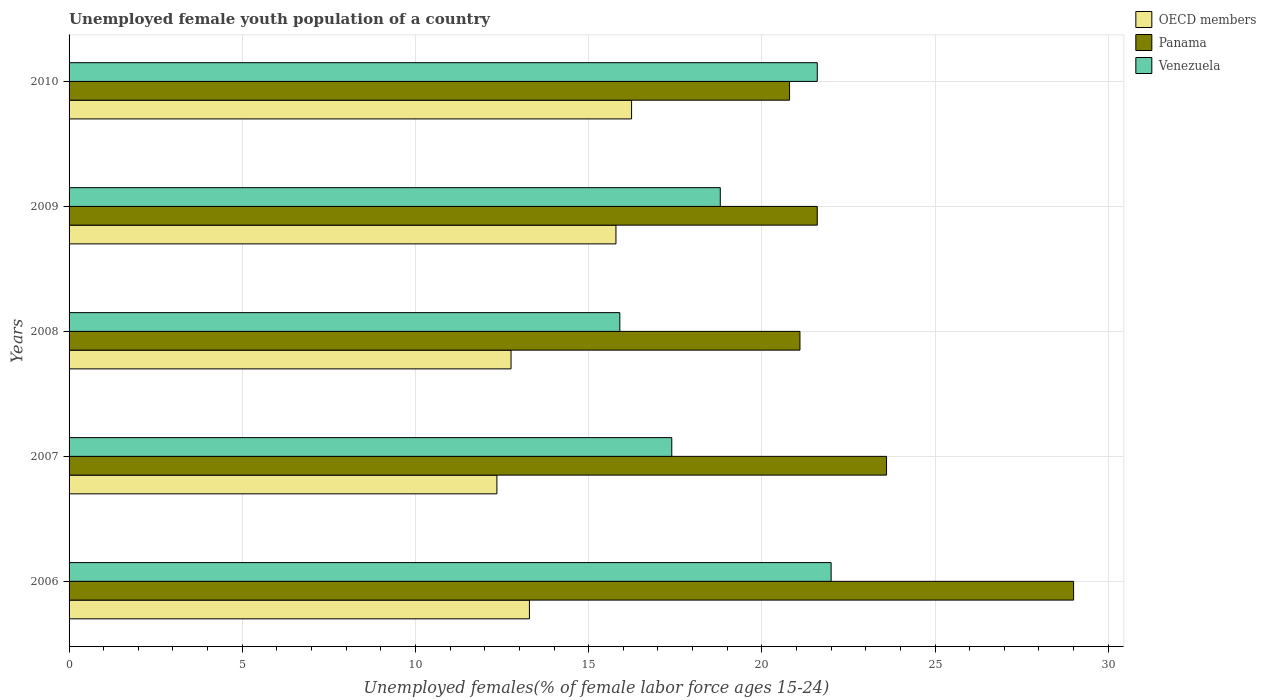How many groups of bars are there?
Your answer should be compact. 5. How many bars are there on the 3rd tick from the bottom?
Your response must be concise. 3. What is the label of the 1st group of bars from the top?
Your response must be concise. 2010. What is the percentage of unemployed female youth population in Venezuela in 2010?
Your answer should be compact. 21.6. Across all years, what is the minimum percentage of unemployed female youth population in Panama?
Your answer should be very brief. 20.8. What is the total percentage of unemployed female youth population in Venezuela in the graph?
Your answer should be compact. 95.7. What is the difference between the percentage of unemployed female youth population in OECD members in 2006 and that in 2010?
Your response must be concise. -2.95. What is the difference between the percentage of unemployed female youth population in Venezuela in 2006 and the percentage of unemployed female youth population in OECD members in 2010?
Give a very brief answer. 5.76. What is the average percentage of unemployed female youth population in OECD members per year?
Offer a very short reply. 14.09. In the year 2009, what is the difference between the percentage of unemployed female youth population in Venezuela and percentage of unemployed female youth population in OECD members?
Provide a succinct answer. 3.01. What is the ratio of the percentage of unemployed female youth population in Panama in 2007 to that in 2009?
Keep it short and to the point. 1.09. Is the percentage of unemployed female youth population in Venezuela in 2006 less than that in 2010?
Ensure brevity in your answer.  No. Is the difference between the percentage of unemployed female youth population in Venezuela in 2006 and 2007 greater than the difference between the percentage of unemployed female youth population in OECD members in 2006 and 2007?
Your answer should be very brief. Yes. What is the difference between the highest and the second highest percentage of unemployed female youth population in Panama?
Make the answer very short. 5.4. What is the difference between the highest and the lowest percentage of unemployed female youth population in OECD members?
Offer a very short reply. 3.89. In how many years, is the percentage of unemployed female youth population in Panama greater than the average percentage of unemployed female youth population in Panama taken over all years?
Your answer should be very brief. 2. Is the sum of the percentage of unemployed female youth population in Venezuela in 2008 and 2009 greater than the maximum percentage of unemployed female youth population in Panama across all years?
Offer a terse response. Yes. What does the 3rd bar from the top in 2010 represents?
Provide a short and direct response. OECD members. What does the 1st bar from the bottom in 2009 represents?
Give a very brief answer. OECD members. How many years are there in the graph?
Your answer should be compact. 5. What is the difference between two consecutive major ticks on the X-axis?
Provide a succinct answer. 5. Are the values on the major ticks of X-axis written in scientific E-notation?
Offer a terse response. No. Where does the legend appear in the graph?
Provide a short and direct response. Top right. How are the legend labels stacked?
Offer a terse response. Vertical. What is the title of the graph?
Ensure brevity in your answer.  Unemployed female youth population of a country. Does "Macao" appear as one of the legend labels in the graph?
Ensure brevity in your answer.  No. What is the label or title of the X-axis?
Provide a succinct answer. Unemployed females(% of female labor force ages 15-24). What is the Unemployed females(% of female labor force ages 15-24) of OECD members in 2006?
Your answer should be very brief. 13.29. What is the Unemployed females(% of female labor force ages 15-24) of OECD members in 2007?
Keep it short and to the point. 12.35. What is the Unemployed females(% of female labor force ages 15-24) in Panama in 2007?
Ensure brevity in your answer.  23.6. What is the Unemployed females(% of female labor force ages 15-24) in Venezuela in 2007?
Your response must be concise. 17.4. What is the Unemployed females(% of female labor force ages 15-24) in OECD members in 2008?
Your response must be concise. 12.76. What is the Unemployed females(% of female labor force ages 15-24) in Panama in 2008?
Give a very brief answer. 21.1. What is the Unemployed females(% of female labor force ages 15-24) in Venezuela in 2008?
Provide a short and direct response. 15.9. What is the Unemployed females(% of female labor force ages 15-24) in OECD members in 2009?
Your answer should be very brief. 15.79. What is the Unemployed females(% of female labor force ages 15-24) in Panama in 2009?
Offer a very short reply. 21.6. What is the Unemployed females(% of female labor force ages 15-24) in Venezuela in 2009?
Provide a succinct answer. 18.8. What is the Unemployed females(% of female labor force ages 15-24) in OECD members in 2010?
Provide a short and direct response. 16.24. What is the Unemployed females(% of female labor force ages 15-24) of Panama in 2010?
Provide a succinct answer. 20.8. What is the Unemployed females(% of female labor force ages 15-24) of Venezuela in 2010?
Offer a terse response. 21.6. Across all years, what is the maximum Unemployed females(% of female labor force ages 15-24) of OECD members?
Offer a terse response. 16.24. Across all years, what is the minimum Unemployed females(% of female labor force ages 15-24) of OECD members?
Your response must be concise. 12.35. Across all years, what is the minimum Unemployed females(% of female labor force ages 15-24) in Panama?
Provide a succinct answer. 20.8. Across all years, what is the minimum Unemployed females(% of female labor force ages 15-24) of Venezuela?
Your answer should be compact. 15.9. What is the total Unemployed females(% of female labor force ages 15-24) of OECD members in the graph?
Your answer should be compact. 70.43. What is the total Unemployed females(% of female labor force ages 15-24) in Panama in the graph?
Offer a terse response. 116.1. What is the total Unemployed females(% of female labor force ages 15-24) in Venezuela in the graph?
Your answer should be very brief. 95.7. What is the difference between the Unemployed females(% of female labor force ages 15-24) in OECD members in 2006 and that in 2007?
Offer a terse response. 0.94. What is the difference between the Unemployed females(% of female labor force ages 15-24) in OECD members in 2006 and that in 2008?
Provide a short and direct response. 0.53. What is the difference between the Unemployed females(% of female labor force ages 15-24) of OECD members in 2006 and that in 2009?
Give a very brief answer. -2.5. What is the difference between the Unemployed females(% of female labor force ages 15-24) of Venezuela in 2006 and that in 2009?
Keep it short and to the point. 3.2. What is the difference between the Unemployed females(% of female labor force ages 15-24) in OECD members in 2006 and that in 2010?
Your response must be concise. -2.95. What is the difference between the Unemployed females(% of female labor force ages 15-24) in Panama in 2006 and that in 2010?
Give a very brief answer. 8.2. What is the difference between the Unemployed females(% of female labor force ages 15-24) in OECD members in 2007 and that in 2008?
Make the answer very short. -0.41. What is the difference between the Unemployed females(% of female labor force ages 15-24) of OECD members in 2007 and that in 2009?
Your answer should be very brief. -3.44. What is the difference between the Unemployed females(% of female labor force ages 15-24) of Venezuela in 2007 and that in 2009?
Give a very brief answer. -1.4. What is the difference between the Unemployed females(% of female labor force ages 15-24) of OECD members in 2007 and that in 2010?
Make the answer very short. -3.89. What is the difference between the Unemployed females(% of female labor force ages 15-24) of Venezuela in 2007 and that in 2010?
Your response must be concise. -4.2. What is the difference between the Unemployed females(% of female labor force ages 15-24) of OECD members in 2008 and that in 2009?
Your answer should be very brief. -3.03. What is the difference between the Unemployed females(% of female labor force ages 15-24) of Panama in 2008 and that in 2009?
Your response must be concise. -0.5. What is the difference between the Unemployed females(% of female labor force ages 15-24) of OECD members in 2008 and that in 2010?
Your answer should be compact. -3.48. What is the difference between the Unemployed females(% of female labor force ages 15-24) of Panama in 2008 and that in 2010?
Make the answer very short. 0.3. What is the difference between the Unemployed females(% of female labor force ages 15-24) in OECD members in 2009 and that in 2010?
Provide a succinct answer. -0.45. What is the difference between the Unemployed females(% of female labor force ages 15-24) in Panama in 2009 and that in 2010?
Provide a succinct answer. 0.8. What is the difference between the Unemployed females(% of female labor force ages 15-24) in Venezuela in 2009 and that in 2010?
Keep it short and to the point. -2.8. What is the difference between the Unemployed females(% of female labor force ages 15-24) of OECD members in 2006 and the Unemployed females(% of female labor force ages 15-24) of Panama in 2007?
Provide a succinct answer. -10.31. What is the difference between the Unemployed females(% of female labor force ages 15-24) of OECD members in 2006 and the Unemployed females(% of female labor force ages 15-24) of Venezuela in 2007?
Ensure brevity in your answer.  -4.11. What is the difference between the Unemployed females(% of female labor force ages 15-24) in OECD members in 2006 and the Unemployed females(% of female labor force ages 15-24) in Panama in 2008?
Your response must be concise. -7.81. What is the difference between the Unemployed females(% of female labor force ages 15-24) in OECD members in 2006 and the Unemployed females(% of female labor force ages 15-24) in Venezuela in 2008?
Offer a very short reply. -2.61. What is the difference between the Unemployed females(% of female labor force ages 15-24) in OECD members in 2006 and the Unemployed females(% of female labor force ages 15-24) in Panama in 2009?
Offer a terse response. -8.31. What is the difference between the Unemployed females(% of female labor force ages 15-24) in OECD members in 2006 and the Unemployed females(% of female labor force ages 15-24) in Venezuela in 2009?
Provide a short and direct response. -5.51. What is the difference between the Unemployed females(% of female labor force ages 15-24) of OECD members in 2006 and the Unemployed females(% of female labor force ages 15-24) of Panama in 2010?
Keep it short and to the point. -7.51. What is the difference between the Unemployed females(% of female labor force ages 15-24) in OECD members in 2006 and the Unemployed females(% of female labor force ages 15-24) in Venezuela in 2010?
Keep it short and to the point. -8.31. What is the difference between the Unemployed females(% of female labor force ages 15-24) in Panama in 2006 and the Unemployed females(% of female labor force ages 15-24) in Venezuela in 2010?
Your response must be concise. 7.4. What is the difference between the Unemployed females(% of female labor force ages 15-24) of OECD members in 2007 and the Unemployed females(% of female labor force ages 15-24) of Panama in 2008?
Your response must be concise. -8.75. What is the difference between the Unemployed females(% of female labor force ages 15-24) in OECD members in 2007 and the Unemployed females(% of female labor force ages 15-24) in Venezuela in 2008?
Your answer should be very brief. -3.55. What is the difference between the Unemployed females(% of female labor force ages 15-24) of OECD members in 2007 and the Unemployed females(% of female labor force ages 15-24) of Panama in 2009?
Keep it short and to the point. -9.25. What is the difference between the Unemployed females(% of female labor force ages 15-24) of OECD members in 2007 and the Unemployed females(% of female labor force ages 15-24) of Venezuela in 2009?
Ensure brevity in your answer.  -6.45. What is the difference between the Unemployed females(% of female labor force ages 15-24) in OECD members in 2007 and the Unemployed females(% of female labor force ages 15-24) in Panama in 2010?
Provide a succinct answer. -8.45. What is the difference between the Unemployed females(% of female labor force ages 15-24) of OECD members in 2007 and the Unemployed females(% of female labor force ages 15-24) of Venezuela in 2010?
Your answer should be compact. -9.25. What is the difference between the Unemployed females(% of female labor force ages 15-24) in Panama in 2007 and the Unemployed females(% of female labor force ages 15-24) in Venezuela in 2010?
Your response must be concise. 2. What is the difference between the Unemployed females(% of female labor force ages 15-24) of OECD members in 2008 and the Unemployed females(% of female labor force ages 15-24) of Panama in 2009?
Your response must be concise. -8.84. What is the difference between the Unemployed females(% of female labor force ages 15-24) of OECD members in 2008 and the Unemployed females(% of female labor force ages 15-24) of Venezuela in 2009?
Provide a succinct answer. -6.04. What is the difference between the Unemployed females(% of female labor force ages 15-24) in OECD members in 2008 and the Unemployed females(% of female labor force ages 15-24) in Panama in 2010?
Provide a short and direct response. -8.04. What is the difference between the Unemployed females(% of female labor force ages 15-24) in OECD members in 2008 and the Unemployed females(% of female labor force ages 15-24) in Venezuela in 2010?
Provide a short and direct response. -8.84. What is the difference between the Unemployed females(% of female labor force ages 15-24) in Panama in 2008 and the Unemployed females(% of female labor force ages 15-24) in Venezuela in 2010?
Your answer should be very brief. -0.5. What is the difference between the Unemployed females(% of female labor force ages 15-24) in OECD members in 2009 and the Unemployed females(% of female labor force ages 15-24) in Panama in 2010?
Your response must be concise. -5.01. What is the difference between the Unemployed females(% of female labor force ages 15-24) of OECD members in 2009 and the Unemployed females(% of female labor force ages 15-24) of Venezuela in 2010?
Offer a very short reply. -5.81. What is the average Unemployed females(% of female labor force ages 15-24) in OECD members per year?
Make the answer very short. 14.09. What is the average Unemployed females(% of female labor force ages 15-24) in Panama per year?
Make the answer very short. 23.22. What is the average Unemployed females(% of female labor force ages 15-24) of Venezuela per year?
Offer a terse response. 19.14. In the year 2006, what is the difference between the Unemployed females(% of female labor force ages 15-24) of OECD members and Unemployed females(% of female labor force ages 15-24) of Panama?
Offer a terse response. -15.71. In the year 2006, what is the difference between the Unemployed females(% of female labor force ages 15-24) in OECD members and Unemployed females(% of female labor force ages 15-24) in Venezuela?
Ensure brevity in your answer.  -8.71. In the year 2007, what is the difference between the Unemployed females(% of female labor force ages 15-24) of OECD members and Unemployed females(% of female labor force ages 15-24) of Panama?
Your answer should be compact. -11.25. In the year 2007, what is the difference between the Unemployed females(% of female labor force ages 15-24) in OECD members and Unemployed females(% of female labor force ages 15-24) in Venezuela?
Offer a very short reply. -5.05. In the year 2007, what is the difference between the Unemployed females(% of female labor force ages 15-24) of Panama and Unemployed females(% of female labor force ages 15-24) of Venezuela?
Offer a terse response. 6.2. In the year 2008, what is the difference between the Unemployed females(% of female labor force ages 15-24) of OECD members and Unemployed females(% of female labor force ages 15-24) of Panama?
Give a very brief answer. -8.34. In the year 2008, what is the difference between the Unemployed females(% of female labor force ages 15-24) in OECD members and Unemployed females(% of female labor force ages 15-24) in Venezuela?
Your response must be concise. -3.14. In the year 2009, what is the difference between the Unemployed females(% of female labor force ages 15-24) of OECD members and Unemployed females(% of female labor force ages 15-24) of Panama?
Provide a succinct answer. -5.81. In the year 2009, what is the difference between the Unemployed females(% of female labor force ages 15-24) in OECD members and Unemployed females(% of female labor force ages 15-24) in Venezuela?
Make the answer very short. -3.01. In the year 2009, what is the difference between the Unemployed females(% of female labor force ages 15-24) of Panama and Unemployed females(% of female labor force ages 15-24) of Venezuela?
Give a very brief answer. 2.8. In the year 2010, what is the difference between the Unemployed females(% of female labor force ages 15-24) of OECD members and Unemployed females(% of female labor force ages 15-24) of Panama?
Provide a short and direct response. -4.56. In the year 2010, what is the difference between the Unemployed females(% of female labor force ages 15-24) in OECD members and Unemployed females(% of female labor force ages 15-24) in Venezuela?
Provide a short and direct response. -5.36. What is the ratio of the Unemployed females(% of female labor force ages 15-24) of OECD members in 2006 to that in 2007?
Keep it short and to the point. 1.08. What is the ratio of the Unemployed females(% of female labor force ages 15-24) in Panama in 2006 to that in 2007?
Offer a terse response. 1.23. What is the ratio of the Unemployed females(% of female labor force ages 15-24) in Venezuela in 2006 to that in 2007?
Provide a short and direct response. 1.26. What is the ratio of the Unemployed females(% of female labor force ages 15-24) in OECD members in 2006 to that in 2008?
Provide a succinct answer. 1.04. What is the ratio of the Unemployed females(% of female labor force ages 15-24) of Panama in 2006 to that in 2008?
Provide a short and direct response. 1.37. What is the ratio of the Unemployed females(% of female labor force ages 15-24) in Venezuela in 2006 to that in 2008?
Your response must be concise. 1.38. What is the ratio of the Unemployed females(% of female labor force ages 15-24) of OECD members in 2006 to that in 2009?
Offer a very short reply. 0.84. What is the ratio of the Unemployed females(% of female labor force ages 15-24) of Panama in 2006 to that in 2009?
Offer a very short reply. 1.34. What is the ratio of the Unemployed females(% of female labor force ages 15-24) of Venezuela in 2006 to that in 2009?
Offer a very short reply. 1.17. What is the ratio of the Unemployed females(% of female labor force ages 15-24) of OECD members in 2006 to that in 2010?
Ensure brevity in your answer.  0.82. What is the ratio of the Unemployed females(% of female labor force ages 15-24) in Panama in 2006 to that in 2010?
Your answer should be very brief. 1.39. What is the ratio of the Unemployed females(% of female labor force ages 15-24) of Venezuela in 2006 to that in 2010?
Keep it short and to the point. 1.02. What is the ratio of the Unemployed females(% of female labor force ages 15-24) in Panama in 2007 to that in 2008?
Provide a succinct answer. 1.12. What is the ratio of the Unemployed females(% of female labor force ages 15-24) in Venezuela in 2007 to that in 2008?
Offer a terse response. 1.09. What is the ratio of the Unemployed females(% of female labor force ages 15-24) in OECD members in 2007 to that in 2009?
Your answer should be very brief. 0.78. What is the ratio of the Unemployed females(% of female labor force ages 15-24) in Panama in 2007 to that in 2009?
Offer a very short reply. 1.09. What is the ratio of the Unemployed females(% of female labor force ages 15-24) of Venezuela in 2007 to that in 2009?
Your response must be concise. 0.93. What is the ratio of the Unemployed females(% of female labor force ages 15-24) in OECD members in 2007 to that in 2010?
Provide a short and direct response. 0.76. What is the ratio of the Unemployed females(% of female labor force ages 15-24) in Panama in 2007 to that in 2010?
Make the answer very short. 1.13. What is the ratio of the Unemployed females(% of female labor force ages 15-24) in Venezuela in 2007 to that in 2010?
Offer a terse response. 0.81. What is the ratio of the Unemployed females(% of female labor force ages 15-24) of OECD members in 2008 to that in 2009?
Your answer should be compact. 0.81. What is the ratio of the Unemployed females(% of female labor force ages 15-24) in Panama in 2008 to that in 2009?
Your response must be concise. 0.98. What is the ratio of the Unemployed females(% of female labor force ages 15-24) of Venezuela in 2008 to that in 2009?
Your response must be concise. 0.85. What is the ratio of the Unemployed females(% of female labor force ages 15-24) in OECD members in 2008 to that in 2010?
Make the answer very short. 0.79. What is the ratio of the Unemployed females(% of female labor force ages 15-24) in Panama in 2008 to that in 2010?
Make the answer very short. 1.01. What is the ratio of the Unemployed females(% of female labor force ages 15-24) in Venezuela in 2008 to that in 2010?
Keep it short and to the point. 0.74. What is the ratio of the Unemployed females(% of female labor force ages 15-24) in OECD members in 2009 to that in 2010?
Ensure brevity in your answer.  0.97. What is the ratio of the Unemployed females(% of female labor force ages 15-24) of Venezuela in 2009 to that in 2010?
Your answer should be compact. 0.87. What is the difference between the highest and the second highest Unemployed females(% of female labor force ages 15-24) in OECD members?
Give a very brief answer. 0.45. What is the difference between the highest and the second highest Unemployed females(% of female labor force ages 15-24) of Venezuela?
Your answer should be very brief. 0.4. What is the difference between the highest and the lowest Unemployed females(% of female labor force ages 15-24) in OECD members?
Offer a terse response. 3.89. What is the difference between the highest and the lowest Unemployed females(% of female labor force ages 15-24) in Venezuela?
Your answer should be compact. 6.1. 